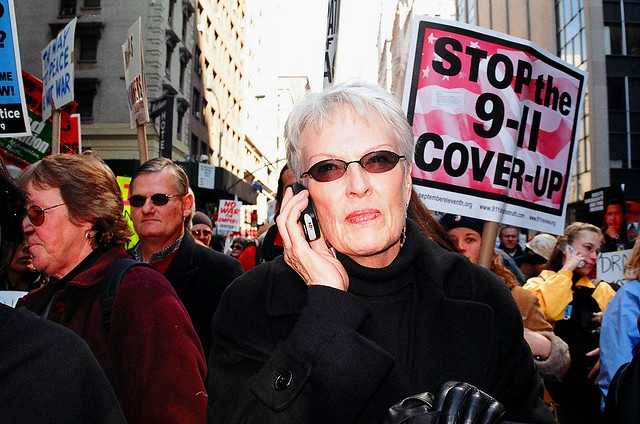Describe the objects in this image and their specific colors. I can see people in gray, black, lightgray, lightpink, and tan tones, people in gray, black, maroon, salmon, and brown tones, people in gray, black, darkgray, lavender, and lightblue tones, people in gray, black, maroon, and brown tones, and people in gray, black, orange, maroon, and brown tones in this image. 